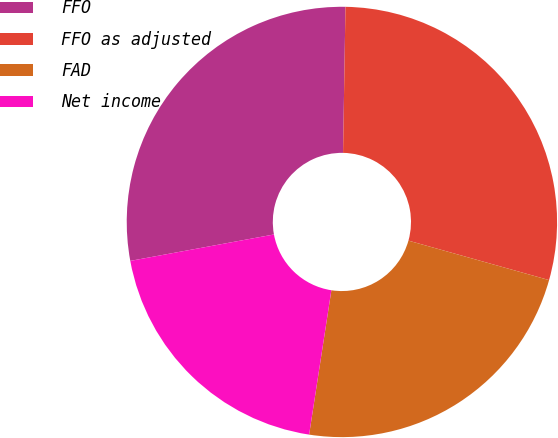Convert chart to OTSL. <chart><loc_0><loc_0><loc_500><loc_500><pie_chart><fcel>FFO<fcel>FFO as adjusted<fcel>FAD<fcel>Net income<nl><fcel>28.16%<fcel>29.09%<fcel>23.08%<fcel>19.67%<nl></chart> 